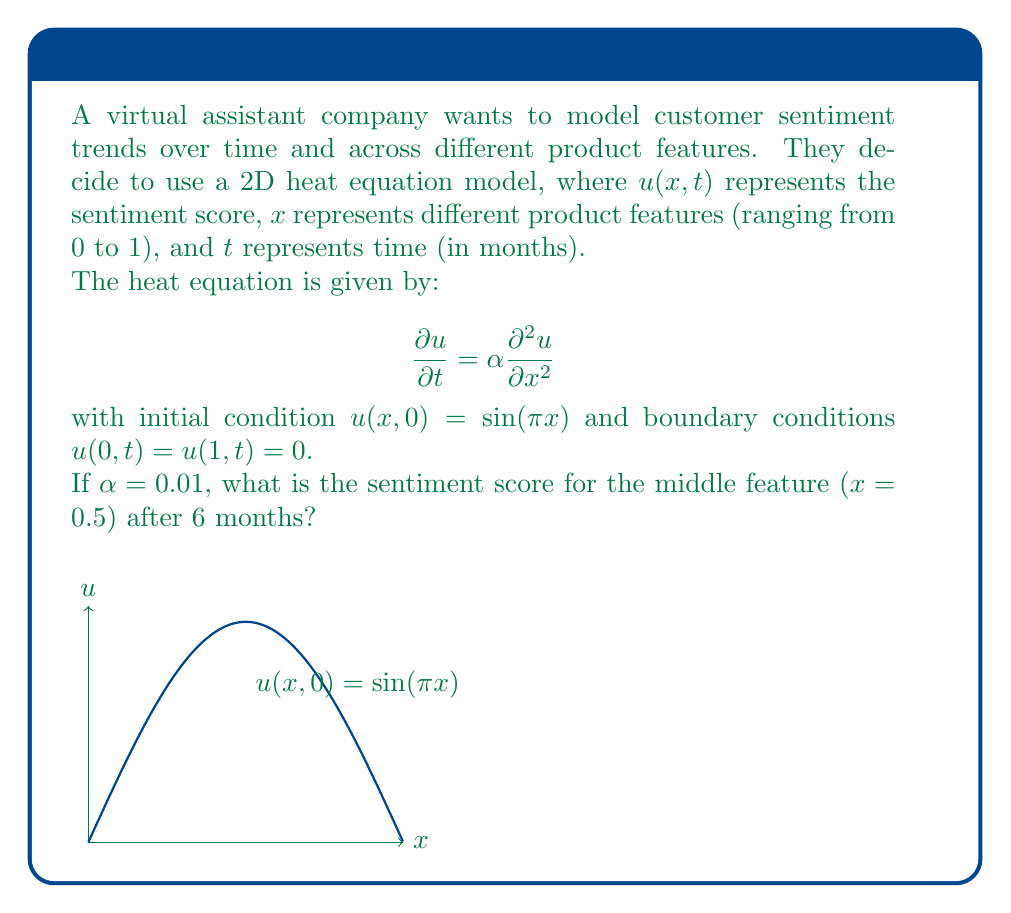Give your solution to this math problem. To solve this problem, we'll use the separation of variables method:

1) The general solution for the heat equation with these boundary conditions is:

   $$u(x,t) = \sum_{n=1}^{\infty} B_n \sin(n\pi x) e^{-\alpha n^2 \pi^2 t}$$

2) Given the initial condition $u(x,0) = \sin(\pi x)$, we can see that only the first term ($n=1$) in the series is non-zero, and $B_1 = 1$. So our solution simplifies to:

   $$u(x,t) = \sin(\pi x) e^{-\alpha \pi^2 t}$$

3) We're asked about the point $x = 0.5$ at time $t = 6$ months. Let's substitute these values:

   $$u(0.5, 6) = \sin(\pi \cdot 0.5) e^{-0.01 \pi^2 \cdot 6}$$

4) Simplify:
   - $\sin(\pi \cdot 0.5) = \sin(\pi/2) = 1$
   - $e^{-0.01 \pi^2 \cdot 6} \approx 0.5525$ (using a calculator)

5) Therefore:

   $$u(0.5, 6) = 1 \cdot 0.5525 \approx 0.5525$$

The sentiment score at $x = 0.5$ after 6 months is approximately 0.5525.
Answer: 0.5525 